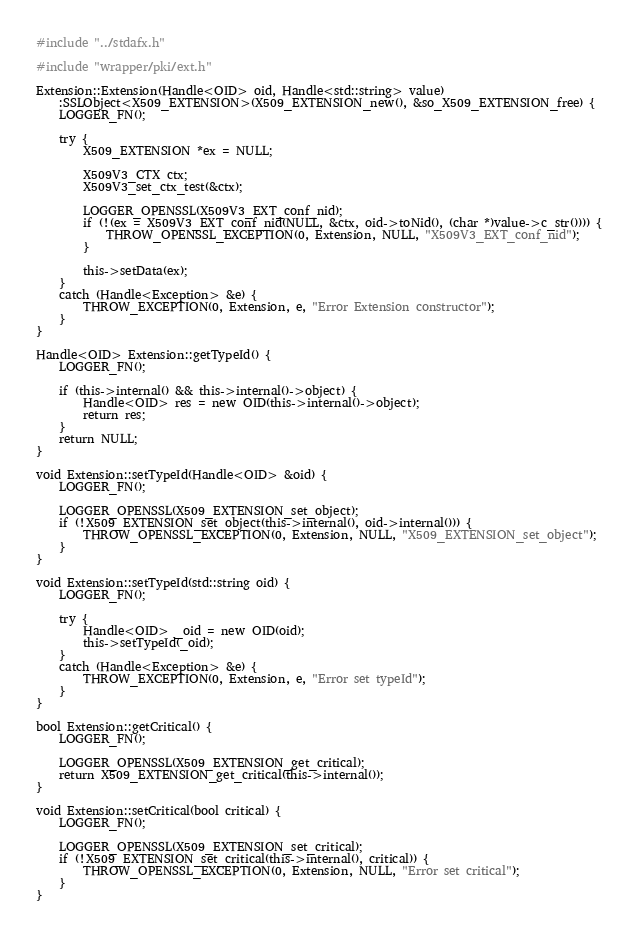Convert code to text. <code><loc_0><loc_0><loc_500><loc_500><_C++_>#include "../stdafx.h"

#include "wrapper/pki/ext.h"

Extension::Extension(Handle<OID> oid, Handle<std::string> value)
	:SSLObject<X509_EXTENSION>(X509_EXTENSION_new(), &so_X509_EXTENSION_free) {
	LOGGER_FN();

	try {
		X509_EXTENSION *ex = NULL;

		X509V3_CTX ctx;
		X509V3_set_ctx_test(&ctx);

		LOGGER_OPENSSL(X509V3_EXT_conf_nid);
		if (!(ex = X509V3_EXT_conf_nid(NULL, &ctx, oid->toNid(), (char *)value->c_str()))) {
			THROW_OPENSSL_EXCEPTION(0, Extension, NULL, "X509V3_EXT_conf_nid");
		}

		this->setData(ex);
	}
	catch (Handle<Exception> &e) {
		THROW_EXCEPTION(0, Extension, e, "Error Extension constructor");
	}	
}

Handle<OID> Extension::getTypeId() {
	LOGGER_FN();

	if (this->internal() && this->internal()->object) {
		Handle<OID> res = new OID(this->internal()->object);
		return res;
	}
	return NULL;
}

void Extension::setTypeId(Handle<OID> &oid) {
	LOGGER_FN();

	LOGGER_OPENSSL(X509_EXTENSION_set_object);
	if (!X509_EXTENSION_set_object(this->internal(), oid->internal())) {
		THROW_OPENSSL_EXCEPTION(0, Extension, NULL, "X509_EXTENSION_set_object");
	}
}

void Extension::setTypeId(std::string oid) {
	LOGGER_FN();

	try {
		Handle<OID> _oid = new OID(oid);
		this->setTypeId(_oid);
	}
	catch (Handle<Exception> &e) {
		THROW_EXCEPTION(0, Extension, e, "Error set typeId");
	}
}

bool Extension::getCritical() {
	LOGGER_FN();

	LOGGER_OPENSSL(X509_EXTENSION_get_critical);
	return X509_EXTENSION_get_critical(this->internal());
}

void Extension::setCritical(bool critical) {
	LOGGER_FN();

	LOGGER_OPENSSL(X509_EXTENSION_set_critical);
	if (!X509_EXTENSION_set_critical(this->internal(), critical)) {
		THROW_OPENSSL_EXCEPTION(0, Extension, NULL, "Error set critical");
	}
}
</code> 